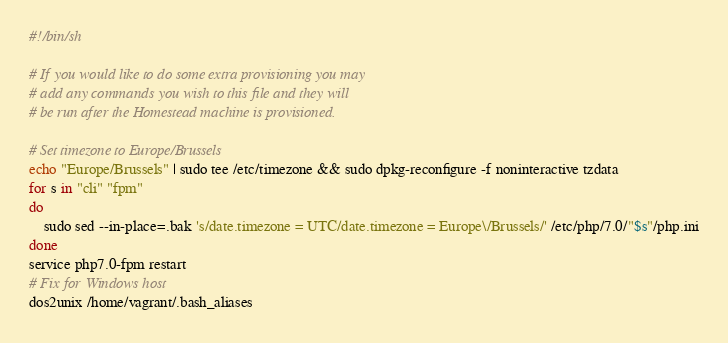Convert code to text. <code><loc_0><loc_0><loc_500><loc_500><_Bash_>#!/bin/sh

# If you would like to do some extra provisioning you may
# add any commands you wish to this file and they will
# be run after the Homestead machine is provisioned.

# Set timezone to Europe/Brussels
echo "Europe/Brussels" | sudo tee /etc/timezone && sudo dpkg-reconfigure -f noninteractive tzdata
for s in "cli" "fpm"
do
    sudo sed --in-place=.bak 's/date.timezone = UTC/date.timezone = Europe\/Brussels/' /etc/php/7.0/"$s"/php.ini
done
service php7.0-fpm restart
# Fix for Windows host
dos2unix /home/vagrant/.bash_aliases</code> 